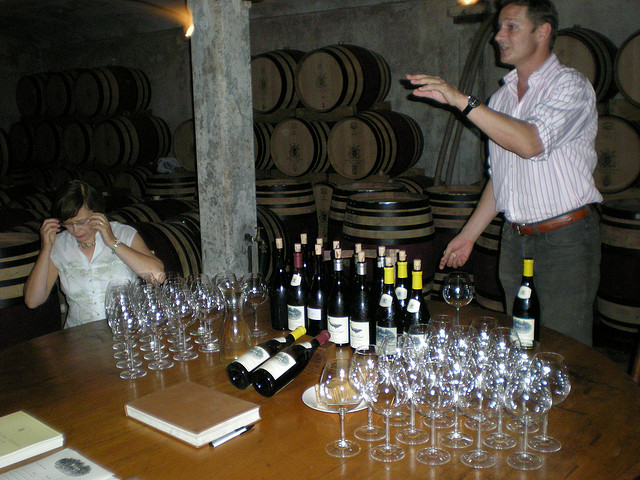Can you tell me more about the wine tasting setup shown in this picture? Certainly! The image shows a wine tasting event, evidenced by the multiple wine bottles on the table, as well as a large array of glasses prepared for the guests. A man appears to be guiding or speaking, possibly about the wines on offer or the winemaking process. Behind them, we can see wooden barrels lined up, indicating that this event is likely taking place in a cellar or winery where the wine is aged. 